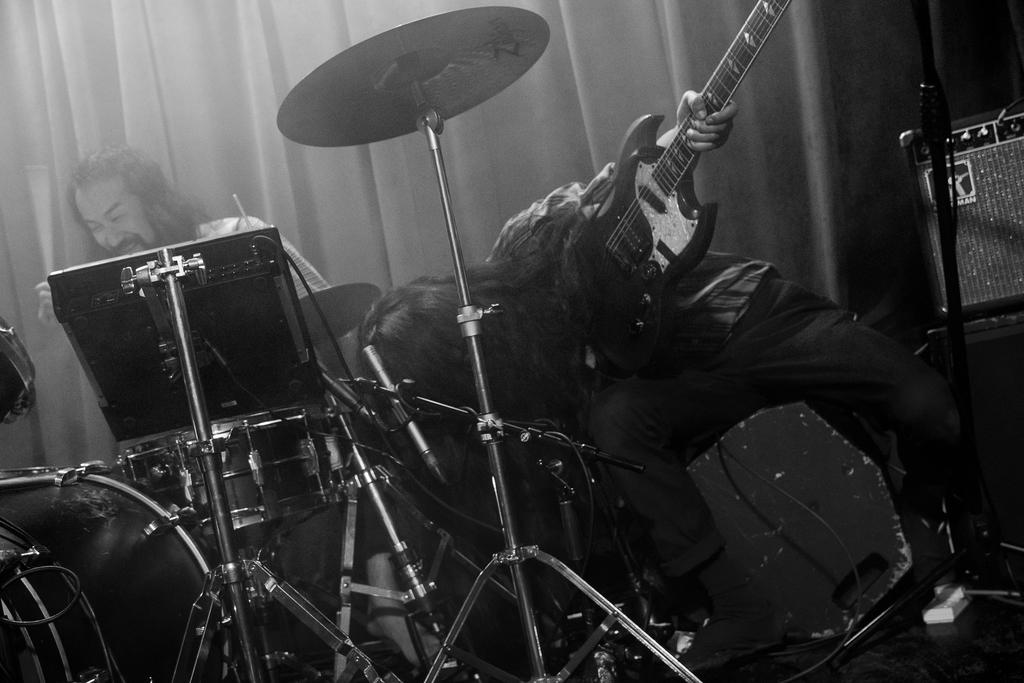How many people are present in the image? There are two people in the image. What is one person holding in the image? One person is holding a guitar. What is the other person doing in the image? The other person is sitting in front of a drum set. What can be seen at the back of the scene? There is a curtain at the back of the scene. What type of rod is being used to make a selection in the image? There is no rod or selection process depicted in the image; it features two people with musical instruments. 